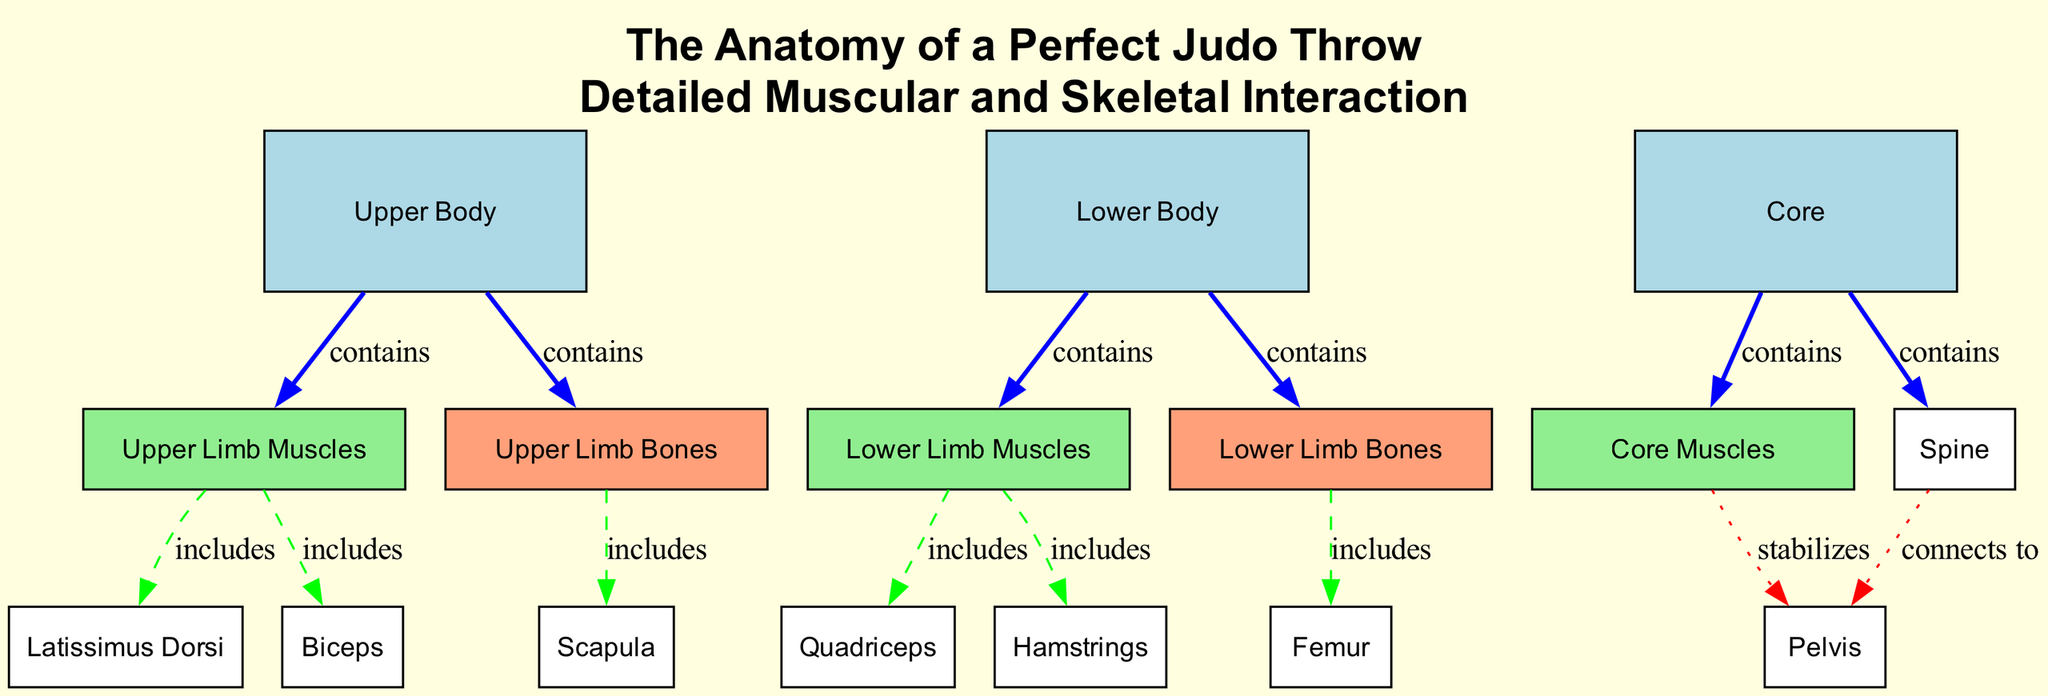What are the three main body areas involved in a judo throw? The diagram lists three main areas: Upper Body, Lower Body, and Core. Each plays a significant role in the mechanics of a judo throw.
Answer: Upper Body, Lower Body, Core Which muscle group is crucial for power and stability in the legs? The diagram indicates that the Quadriceps are included under Lower Limb Muscles and are essential for providing leg power and stability during throws.
Answer: Quadriceps How does the spine connect to the pelvis? According to the diagram, there is a direct connection labeled "connects to," indicating that the spine plays a structural role in connecting these two body parts.
Answer: Connects to How many muscles are included in the Upper Limb Muscles? Upon analyzing the connections, the diagram shows two specific muscles included: Latissimus Dorsi and Biceps, indicating that there are two muscles in this category.
Answer: Two Which group includes the Femur? The Lower Limb Bones node is associated with the Femur, as indicated in the edges of the diagram which show that Lower Limb Bones 'contains' Femur.
Answer: Lower Limb Bones What stabilizes the pelvis? The diagram specifies that Core Muscles stabilize the pelvis, highlighting the importance of core stability in the interplay of muscular and skeletal forces during a judo throw.
Answer: Core Muscles Which muscles are part of the Lower Limb Muscles? The diagram includes both Quadriceps and Hamstrings as part of the Lower Limb Muscles, indicating their significance in providing strength and explosive power in throws.
Answer: Quadriceps, Hamstrings What is included in the Upper Body? The Upper Body node contains both Upper Limb Muscles and Upper Limb Bones, showing that this area comprises both muscular and skeletal components.
Answer: Upper Limb Muscles, Upper Limb Bones How many edges connect nodes in the diagram? By counting the connections, the diagram illustrates a total of 13 edges that establish relationships among various nodes regarding their anatomical functions.
Answer: 13 